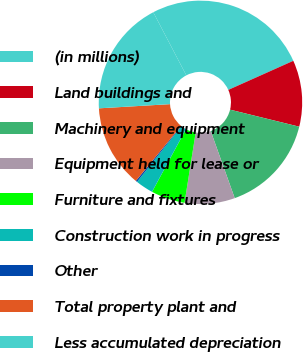Convert chart to OTSL. <chart><loc_0><loc_0><loc_500><loc_500><pie_chart><fcel>(in millions)<fcel>Land buildings and<fcel>Machinery and equipment<fcel>Equipment held for lease or<fcel>Furniture and fixtures<fcel>Construction work in progress<fcel>Other<fcel>Total property plant and<fcel>Less accumulated depreciation<nl><fcel>25.98%<fcel>10.54%<fcel>15.69%<fcel>7.97%<fcel>5.39%<fcel>2.82%<fcel>0.24%<fcel>13.11%<fcel>18.26%<nl></chart> 